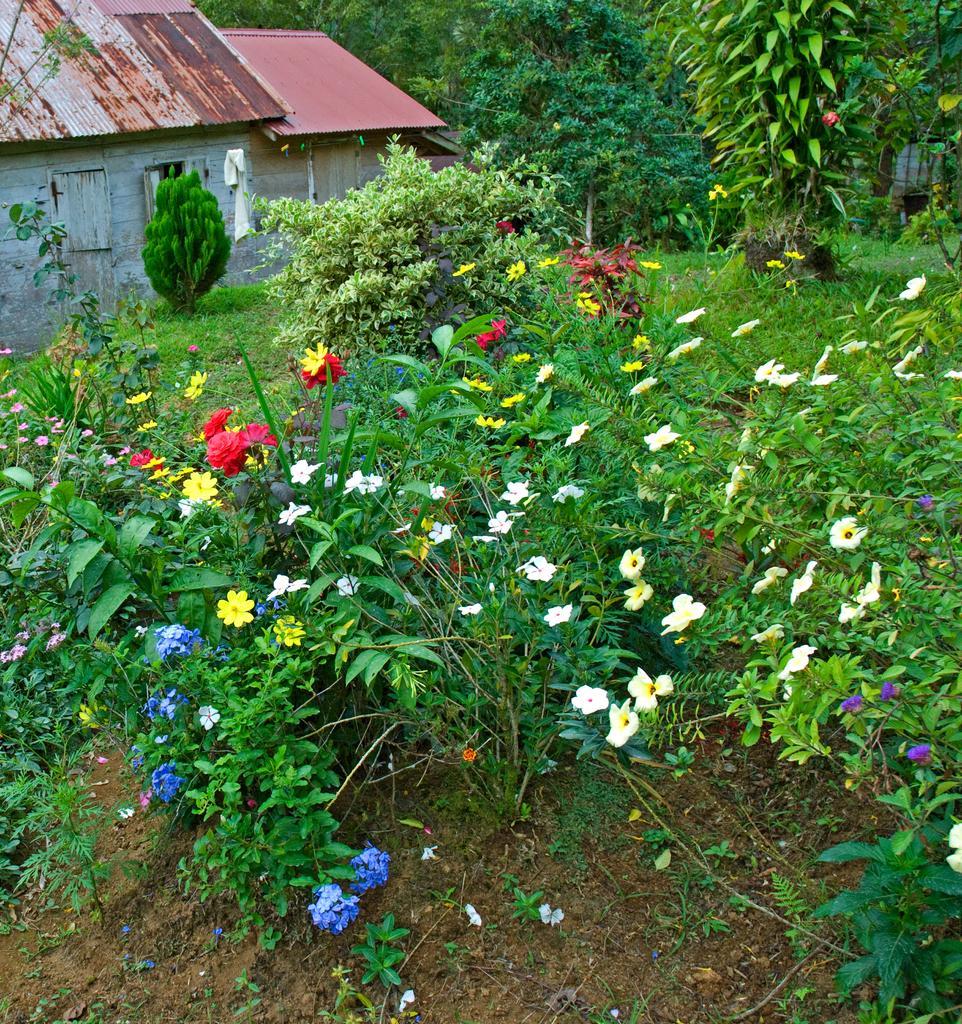Can you describe this image briefly? In the center of the image we can see planets with different colored flowers. In the background, we can see houses, trees, grass and some objects. 